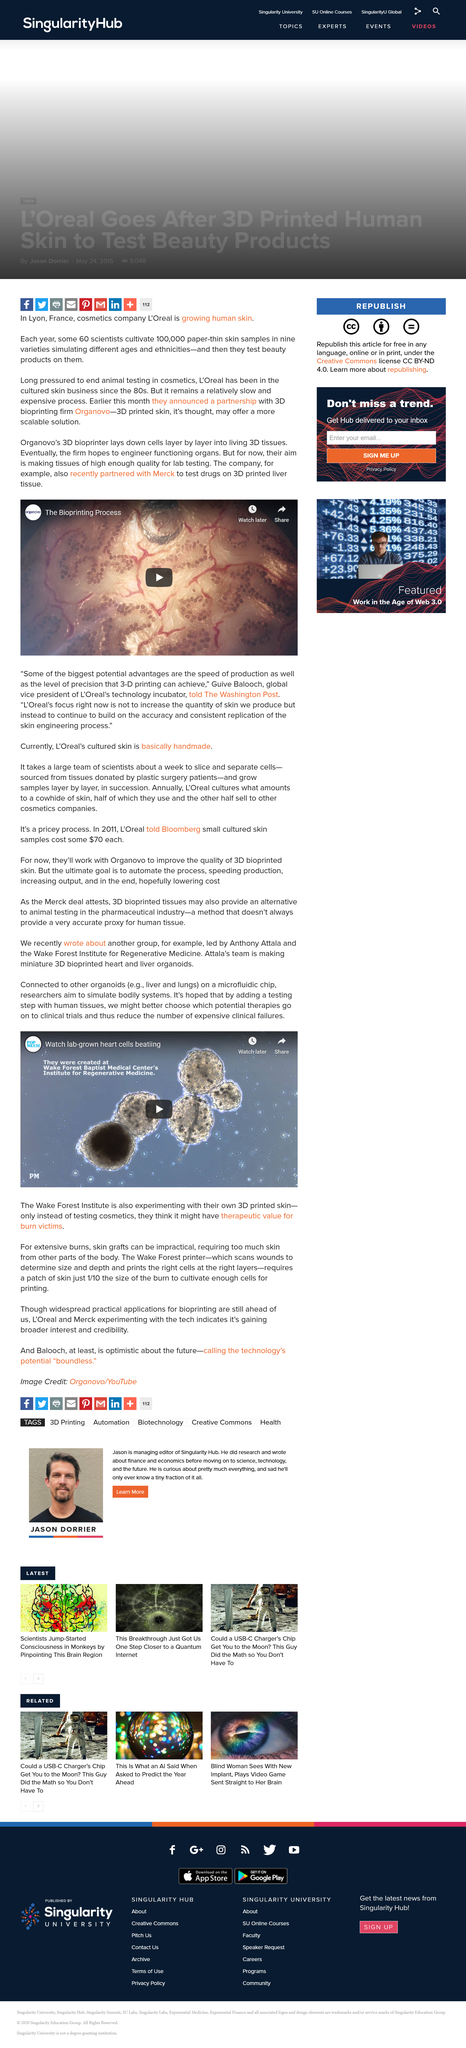Draw attention to some important aspects in this diagram. Organovo's 3D bioprinter is a device that lays down cells layer by layer into living 3D tissues, creating functional, biologically accurate tissue models for drug development and research. Wake Institute aims to simulate bodily systems using skin grafts. We will use a microfluidic chip to attach cells to other organs, allowing for a more accurate and efficient method of studying the interactions between cells and organs. The Wake Forest 3D printer will be used to produce the appropriate amount of skin tissue for surgical reconstruction procedures. Guive Balooch is the global vice president of L'Oreal's technology incubator, and as such, he is an important figure in the beauty industry. 